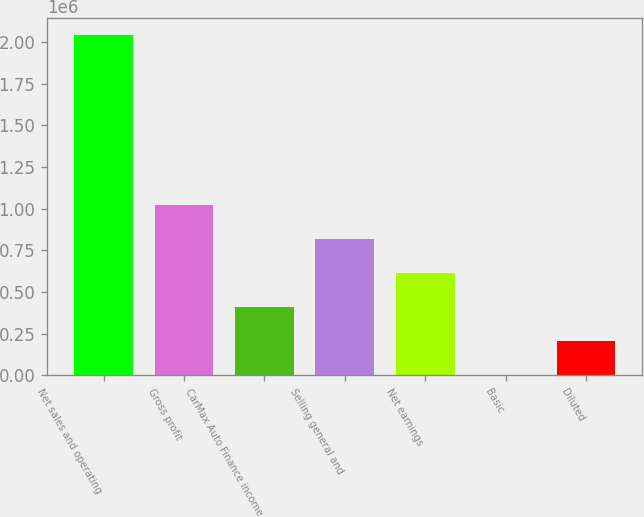Convert chart to OTSL. <chart><loc_0><loc_0><loc_500><loc_500><bar_chart><fcel>Net sales and operating<fcel>Gross profit<fcel>CarMax Auto Finance income<fcel>Selling general and<fcel>Net earnings<fcel>Basic<fcel>Diluted<nl><fcel>2.04461e+06<fcel>1.0223e+06<fcel>408921<fcel>817843<fcel>613382<fcel>0.1<fcel>204461<nl></chart> 